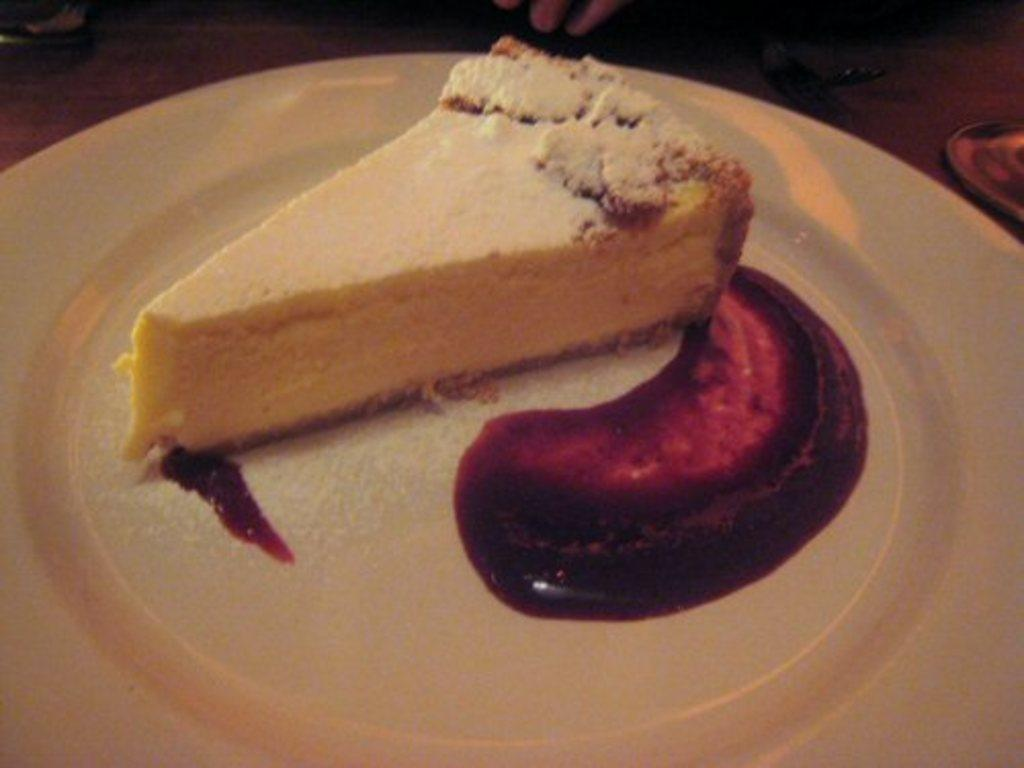What is on the plate in the image? There is a slice of bread on the plate. What color is the plate? The plate is white in color. What is beside the slice of bread on the plate? There is jam beside the slice of bread. What is the person in the image afraid of? There is no person present in the image, so it is not possible to determine what they might be afraid of. 